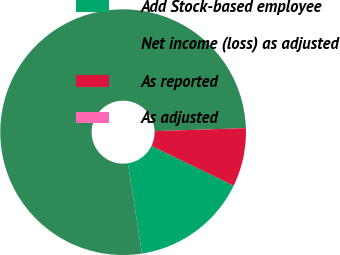Convert chart to OTSL. <chart><loc_0><loc_0><loc_500><loc_500><pie_chart><fcel>Add Stock-based employee<fcel>Net income (loss) as adjusted<fcel>As reported<fcel>As adjusted<nl><fcel>15.38%<fcel>76.92%<fcel>7.69%<fcel>0.0%<nl></chart> 